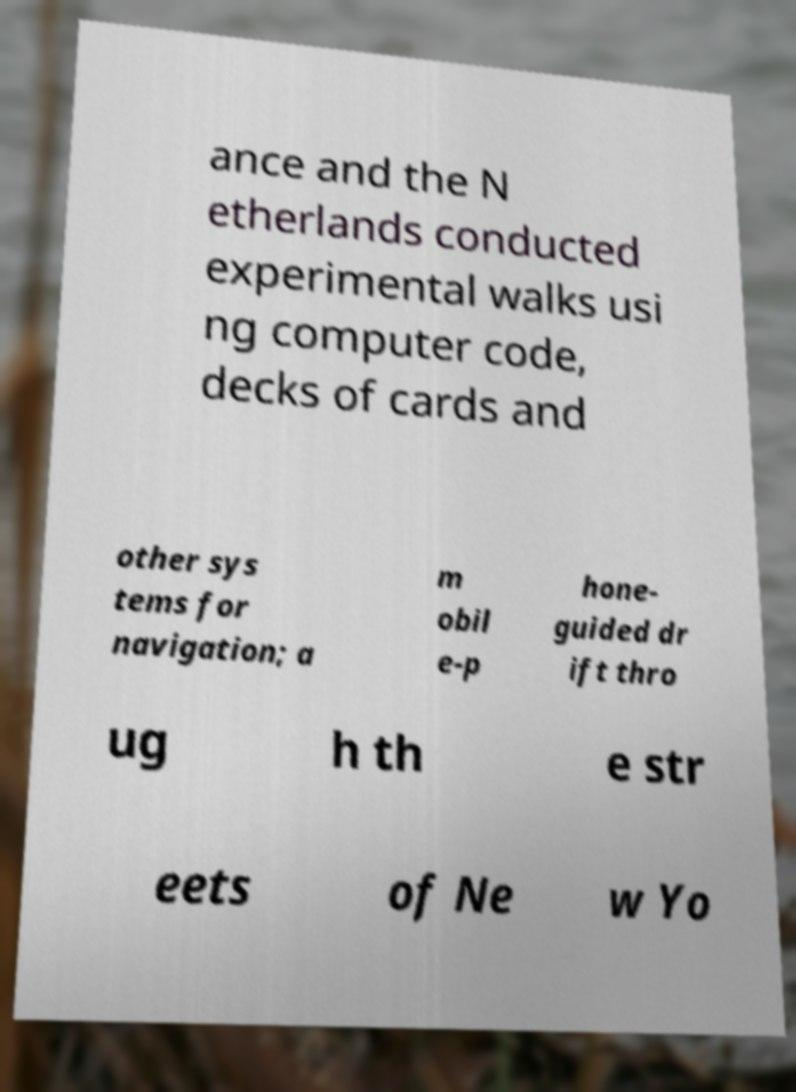I need the written content from this picture converted into text. Can you do that? ance and the N etherlands conducted experimental walks usi ng computer code, decks of cards and other sys tems for navigation; a m obil e-p hone- guided dr ift thro ug h th e str eets of Ne w Yo 